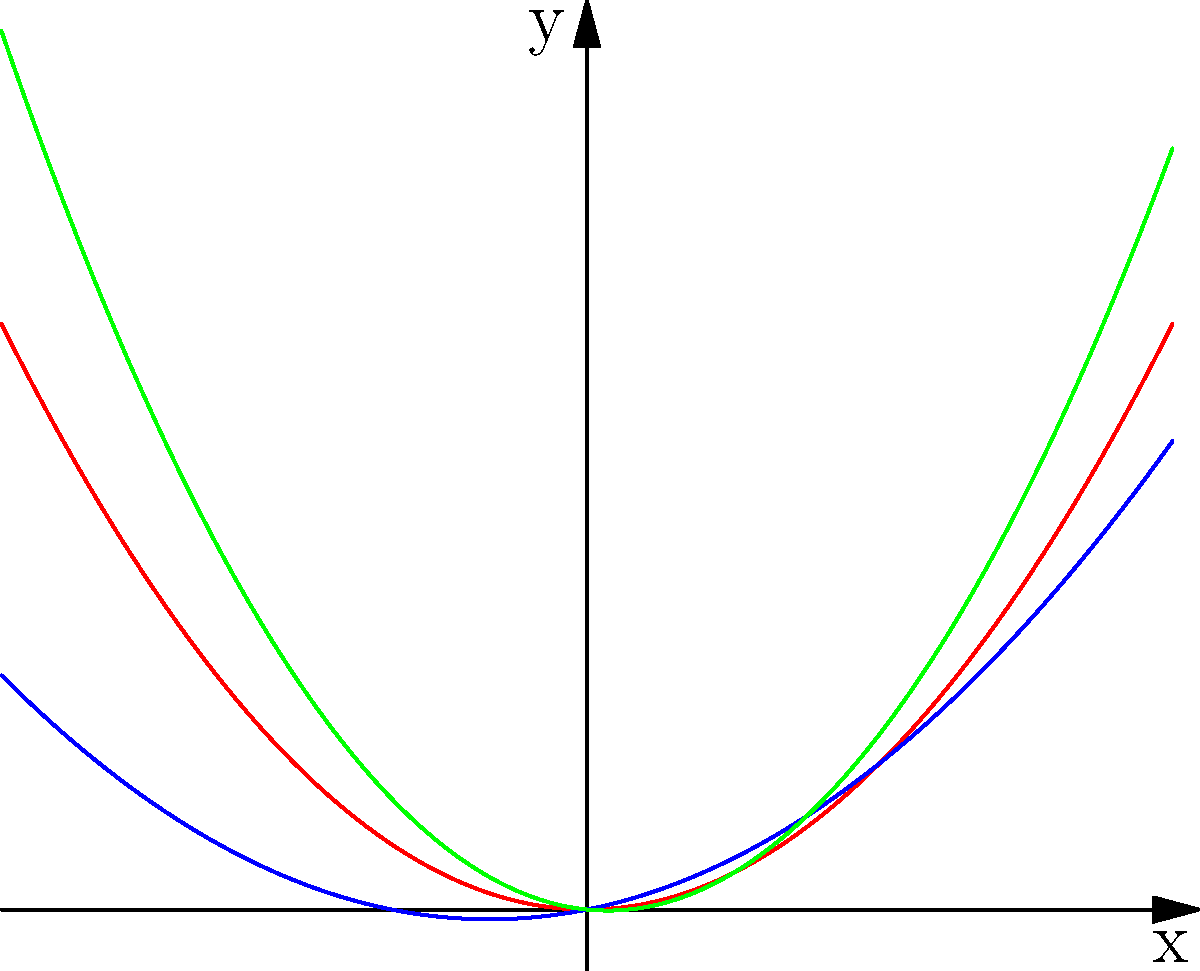The graph shows vector curves representing the scroll shapes of three famous violin models. Which model's scroll shape has the steepest curvature near the origin (x = 0)? To determine which model has the steepest curvature near the origin, we need to analyze the rate of change of each curve at x = 0. This can be done by comparing the second derivatives of the functions at x = 0.

1. Stradivarius (red curve): $f_1(x) = 0.5x^2$
   First derivative: $f_1'(x) = x$
   Second derivative: $f_1''(x) = 1$

2. Guarneri (blue curve): $f_2(x) = 0.3x^2 + 0.2x$
   First derivative: $f_2'(x) = 0.6x + 0.2$
   Second derivative: $f_2''(x) = 0.6$

3. Amati (green curve): $f_3(x) = 0.7x^2 - 0.1x$
   First derivative: $f_3'(x) = 1.4x - 0.1$
   Second derivative: $f_3''(x) = 1.4$

The second derivative represents the curvature of the function. The larger the absolute value of the second derivative, the steeper the curvature.

At x = 0, the second derivatives are:
Stradivarius: 1
Guarneri: 0.6
Amati: 1.4

Therefore, the Amati model has the steepest curvature near the origin.
Answer: Amati 